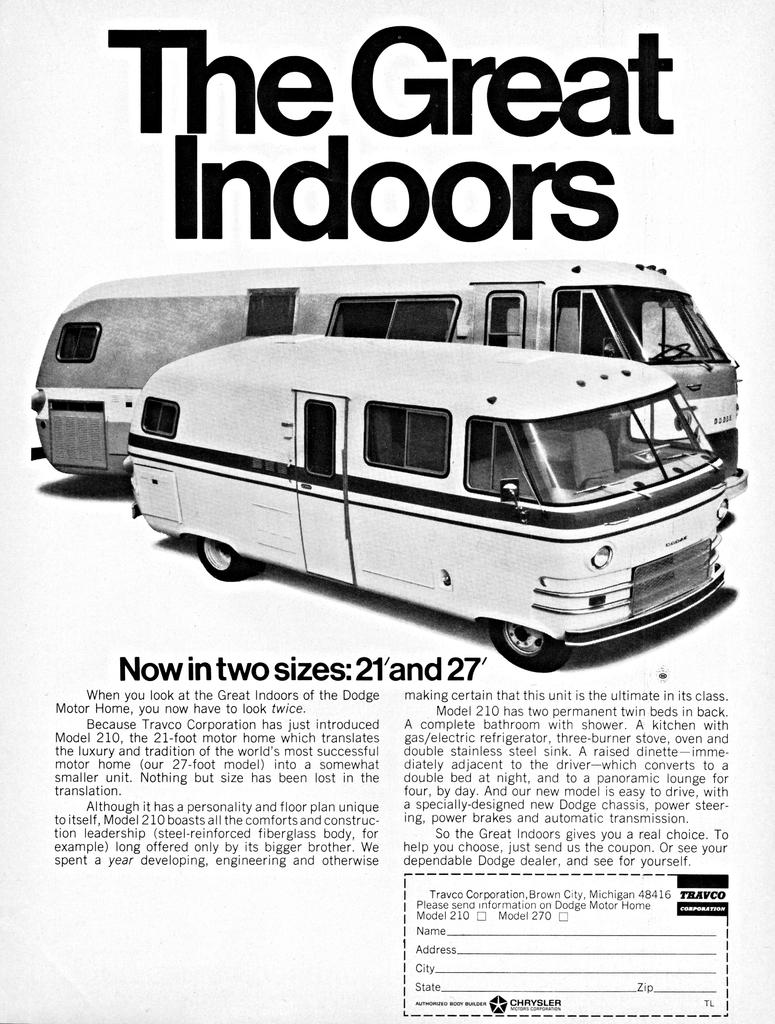What kind of van is this?
Your response must be concise. Dodge motor home. 